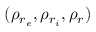<formula> <loc_0><loc_0><loc_500><loc_500>( \rho _ { r _ { e } } , \rho _ { r _ { i } } , \rho _ { r } )</formula> 